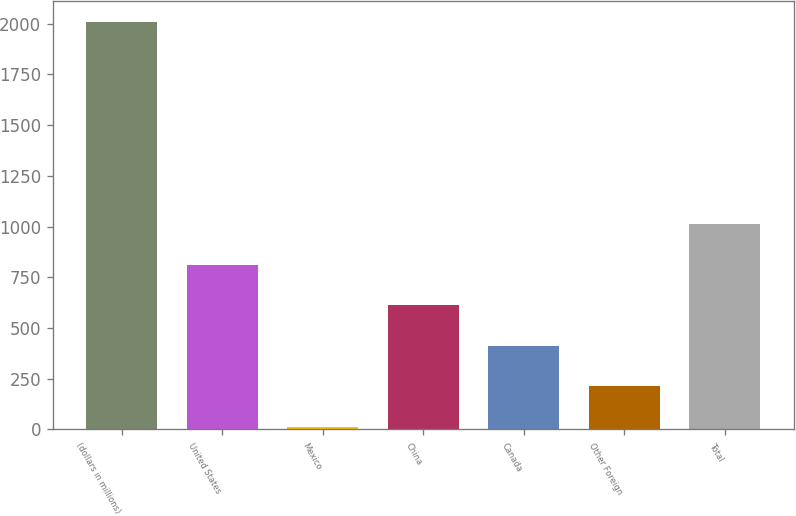Convert chart to OTSL. <chart><loc_0><loc_0><loc_500><loc_500><bar_chart><fcel>(dollars in millions)<fcel>United States<fcel>Mexico<fcel>China<fcel>Canada<fcel>Other Foreign<fcel>Total<nl><fcel>2010<fcel>812.76<fcel>14.6<fcel>613.22<fcel>413.68<fcel>214.14<fcel>1012.3<nl></chart> 